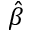<formula> <loc_0><loc_0><loc_500><loc_500>\hat { \beta }</formula> 